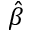<formula> <loc_0><loc_0><loc_500><loc_500>\hat { \beta }</formula> 